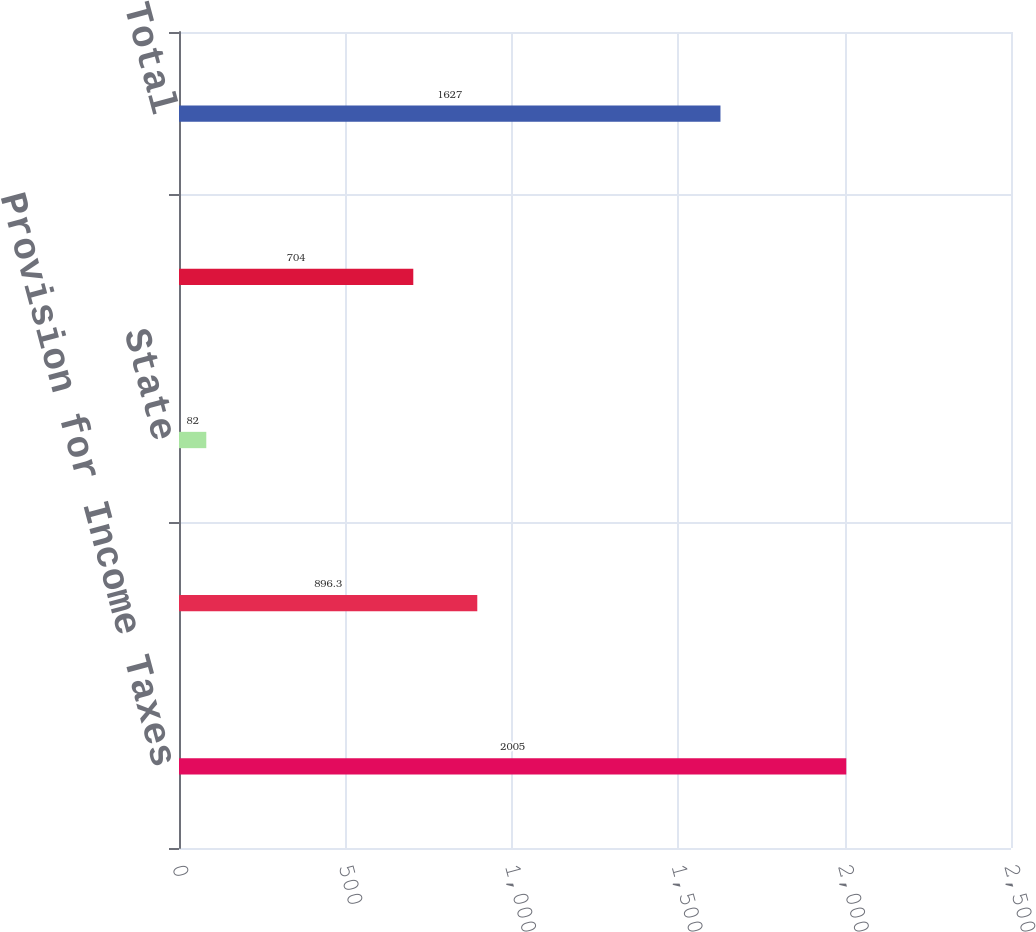Convert chart to OTSL. <chart><loc_0><loc_0><loc_500><loc_500><bar_chart><fcel>Provision for Income Taxes<fcel>Federal<fcel>State<fcel>International<fcel>Total<nl><fcel>2005<fcel>896.3<fcel>82<fcel>704<fcel>1627<nl></chart> 